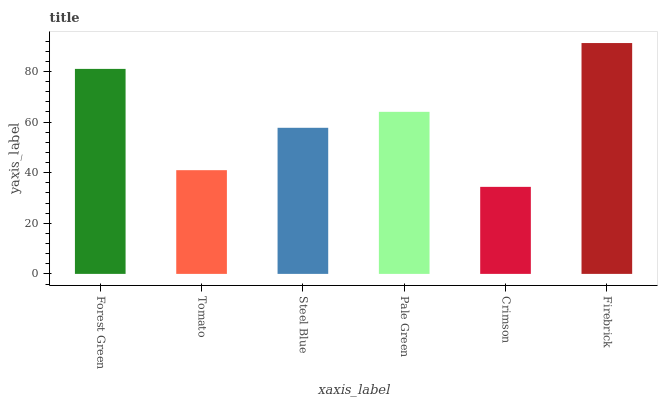Is Crimson the minimum?
Answer yes or no. Yes. Is Firebrick the maximum?
Answer yes or no. Yes. Is Tomato the minimum?
Answer yes or no. No. Is Tomato the maximum?
Answer yes or no. No. Is Forest Green greater than Tomato?
Answer yes or no. Yes. Is Tomato less than Forest Green?
Answer yes or no. Yes. Is Tomato greater than Forest Green?
Answer yes or no. No. Is Forest Green less than Tomato?
Answer yes or no. No. Is Pale Green the high median?
Answer yes or no. Yes. Is Steel Blue the low median?
Answer yes or no. Yes. Is Firebrick the high median?
Answer yes or no. No. Is Forest Green the low median?
Answer yes or no. No. 